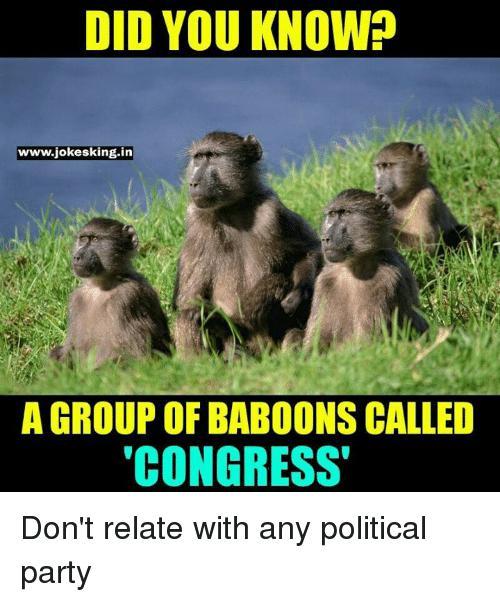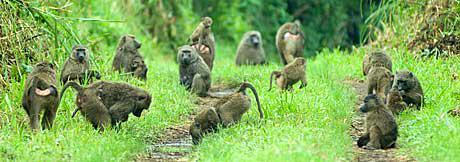The first image is the image on the left, the second image is the image on the right. For the images shown, is this caption "Right image shows a group of baboons gathered but not closely huddled in a field with plant life present." true? Answer yes or no. Yes. The first image is the image on the left, the second image is the image on the right. Assess this claim about the two images: "The animals in the image on the left are near a body of water.". Correct or not? Answer yes or no. Yes. 